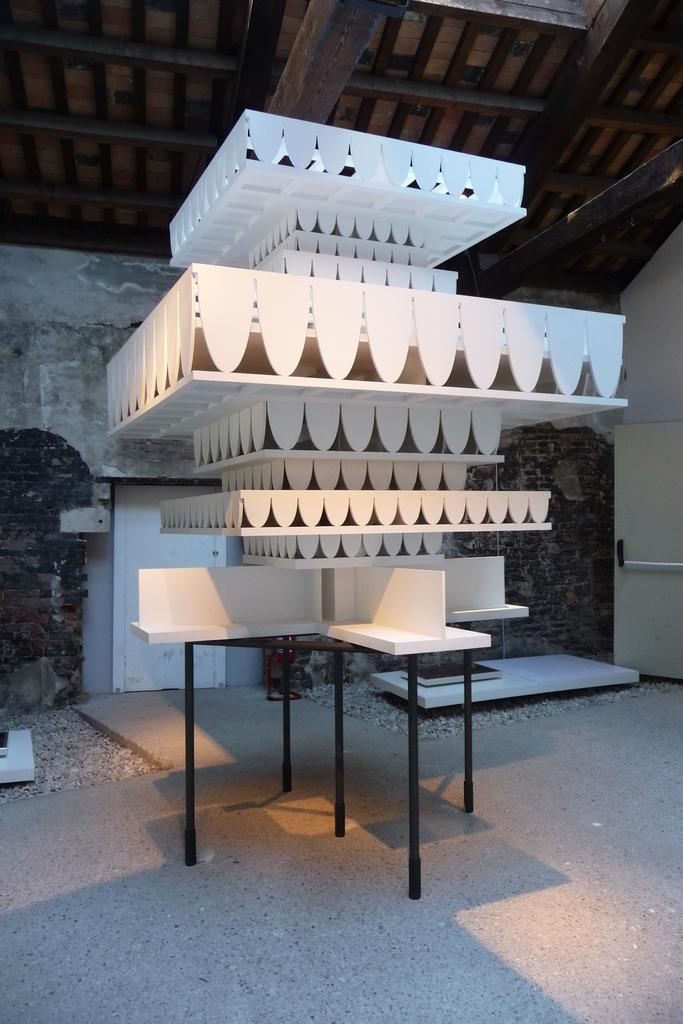What type of structure is visible in the image? There is some architecture in the image. Where is the architecture located? The architecture is on a table in the image. What can be seen in the background of the image? There is a wall in the background of the image. What is visible at the top of the image? The top of the image includes a roof. Are your friends playing with a monkey in the image? There is no mention of friends or a monkey in the image; it features architecture on a table with a wall and roof visible. 